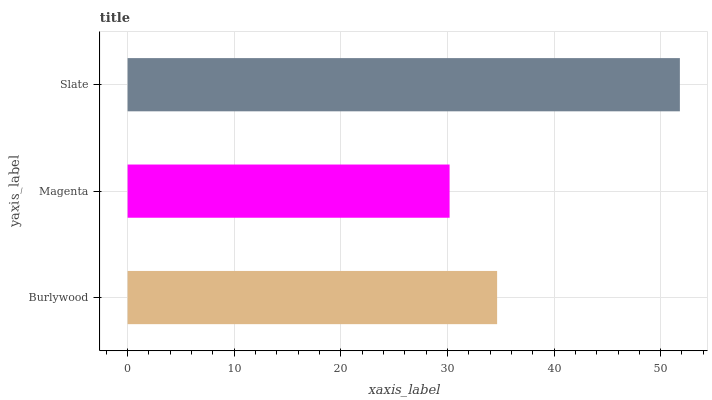Is Magenta the minimum?
Answer yes or no. Yes. Is Slate the maximum?
Answer yes or no. Yes. Is Slate the minimum?
Answer yes or no. No. Is Magenta the maximum?
Answer yes or no. No. Is Slate greater than Magenta?
Answer yes or no. Yes. Is Magenta less than Slate?
Answer yes or no. Yes. Is Magenta greater than Slate?
Answer yes or no. No. Is Slate less than Magenta?
Answer yes or no. No. Is Burlywood the high median?
Answer yes or no. Yes. Is Burlywood the low median?
Answer yes or no. Yes. Is Magenta the high median?
Answer yes or no. No. Is Magenta the low median?
Answer yes or no. No. 